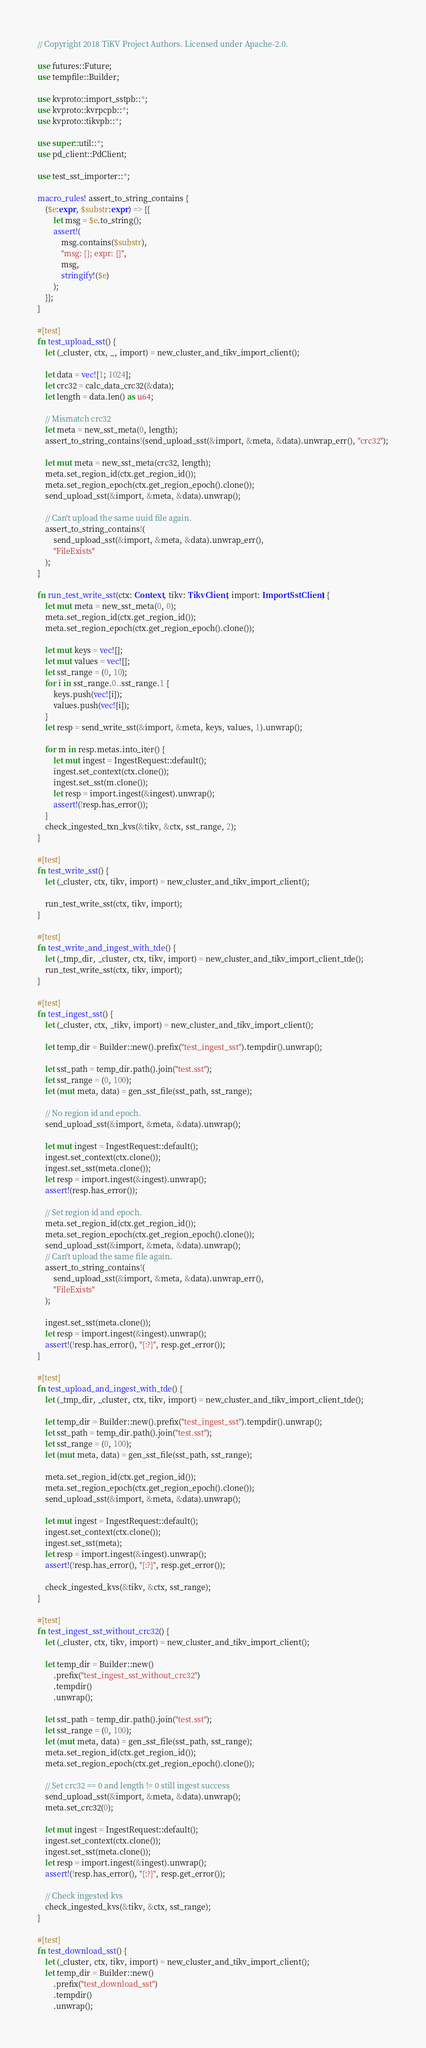Convert code to text. <code><loc_0><loc_0><loc_500><loc_500><_Rust_>// Copyright 2018 TiKV Project Authors. Licensed under Apache-2.0.

use futures::Future;
use tempfile::Builder;

use kvproto::import_sstpb::*;
use kvproto::kvrpcpb::*;
use kvproto::tikvpb::*;

use super::util::*;
use pd_client::PdClient;

use test_sst_importer::*;

macro_rules! assert_to_string_contains {
    ($e:expr, $substr:expr) => {{
        let msg = $e.to_string();
        assert!(
            msg.contains($substr),
            "msg: {}; expr: {}",
            msg,
            stringify!($e)
        );
    }};
}

#[test]
fn test_upload_sst() {
    let (_cluster, ctx, _, import) = new_cluster_and_tikv_import_client();

    let data = vec![1; 1024];
    let crc32 = calc_data_crc32(&data);
    let length = data.len() as u64;

    // Mismatch crc32
    let meta = new_sst_meta(0, length);
    assert_to_string_contains!(send_upload_sst(&import, &meta, &data).unwrap_err(), "crc32");

    let mut meta = new_sst_meta(crc32, length);
    meta.set_region_id(ctx.get_region_id());
    meta.set_region_epoch(ctx.get_region_epoch().clone());
    send_upload_sst(&import, &meta, &data).unwrap();

    // Can't upload the same uuid file again.
    assert_to_string_contains!(
        send_upload_sst(&import, &meta, &data).unwrap_err(),
        "FileExists"
    );
}

fn run_test_write_sst(ctx: Context, tikv: TikvClient, import: ImportSstClient) {
    let mut meta = new_sst_meta(0, 0);
    meta.set_region_id(ctx.get_region_id());
    meta.set_region_epoch(ctx.get_region_epoch().clone());

    let mut keys = vec![];
    let mut values = vec![];
    let sst_range = (0, 10);
    for i in sst_range.0..sst_range.1 {
        keys.push(vec![i]);
        values.push(vec![i]);
    }
    let resp = send_write_sst(&import, &meta, keys, values, 1).unwrap();

    for m in resp.metas.into_iter() {
        let mut ingest = IngestRequest::default();
        ingest.set_context(ctx.clone());
        ingest.set_sst(m.clone());
        let resp = import.ingest(&ingest).unwrap();
        assert!(!resp.has_error());
    }
    check_ingested_txn_kvs(&tikv, &ctx, sst_range, 2);
}

#[test]
fn test_write_sst() {
    let (_cluster, ctx, tikv, import) = new_cluster_and_tikv_import_client();

    run_test_write_sst(ctx, tikv, import);
}

#[test]
fn test_write_and_ingest_with_tde() {
    let (_tmp_dir, _cluster, ctx, tikv, import) = new_cluster_and_tikv_import_client_tde();
    run_test_write_sst(ctx, tikv, import);
}

#[test]
fn test_ingest_sst() {
    let (_cluster, ctx, _tikv, import) = new_cluster_and_tikv_import_client();

    let temp_dir = Builder::new().prefix("test_ingest_sst").tempdir().unwrap();

    let sst_path = temp_dir.path().join("test.sst");
    let sst_range = (0, 100);
    let (mut meta, data) = gen_sst_file(sst_path, sst_range);

    // No region id and epoch.
    send_upload_sst(&import, &meta, &data).unwrap();

    let mut ingest = IngestRequest::default();
    ingest.set_context(ctx.clone());
    ingest.set_sst(meta.clone());
    let resp = import.ingest(&ingest).unwrap();
    assert!(resp.has_error());

    // Set region id and epoch.
    meta.set_region_id(ctx.get_region_id());
    meta.set_region_epoch(ctx.get_region_epoch().clone());
    send_upload_sst(&import, &meta, &data).unwrap();
    // Can't upload the same file again.
    assert_to_string_contains!(
        send_upload_sst(&import, &meta, &data).unwrap_err(),
        "FileExists"
    );

    ingest.set_sst(meta.clone());
    let resp = import.ingest(&ingest).unwrap();
    assert!(!resp.has_error(), "{:?}", resp.get_error());
}

#[test]
fn test_upload_and_ingest_with_tde() {
    let (_tmp_dir, _cluster, ctx, tikv, import) = new_cluster_and_tikv_import_client_tde();

    let temp_dir = Builder::new().prefix("test_ingest_sst").tempdir().unwrap();
    let sst_path = temp_dir.path().join("test.sst");
    let sst_range = (0, 100);
    let (mut meta, data) = gen_sst_file(sst_path, sst_range);

    meta.set_region_id(ctx.get_region_id());
    meta.set_region_epoch(ctx.get_region_epoch().clone());
    send_upload_sst(&import, &meta, &data).unwrap();

    let mut ingest = IngestRequest::default();
    ingest.set_context(ctx.clone());
    ingest.set_sst(meta);
    let resp = import.ingest(&ingest).unwrap();
    assert!(!resp.has_error(), "{:?}", resp.get_error());

    check_ingested_kvs(&tikv, &ctx, sst_range);
}

#[test]
fn test_ingest_sst_without_crc32() {
    let (_cluster, ctx, tikv, import) = new_cluster_and_tikv_import_client();

    let temp_dir = Builder::new()
        .prefix("test_ingest_sst_without_crc32")
        .tempdir()
        .unwrap();

    let sst_path = temp_dir.path().join("test.sst");
    let sst_range = (0, 100);
    let (mut meta, data) = gen_sst_file(sst_path, sst_range);
    meta.set_region_id(ctx.get_region_id());
    meta.set_region_epoch(ctx.get_region_epoch().clone());

    // Set crc32 == 0 and length != 0 still ingest success
    send_upload_sst(&import, &meta, &data).unwrap();
    meta.set_crc32(0);

    let mut ingest = IngestRequest::default();
    ingest.set_context(ctx.clone());
    ingest.set_sst(meta.clone());
    let resp = import.ingest(&ingest).unwrap();
    assert!(!resp.has_error(), "{:?}", resp.get_error());

    // Check ingested kvs
    check_ingested_kvs(&tikv, &ctx, sst_range);
}

#[test]
fn test_download_sst() {
    let (_cluster, ctx, tikv, import) = new_cluster_and_tikv_import_client();
    let temp_dir = Builder::new()
        .prefix("test_download_sst")
        .tempdir()
        .unwrap();
</code> 